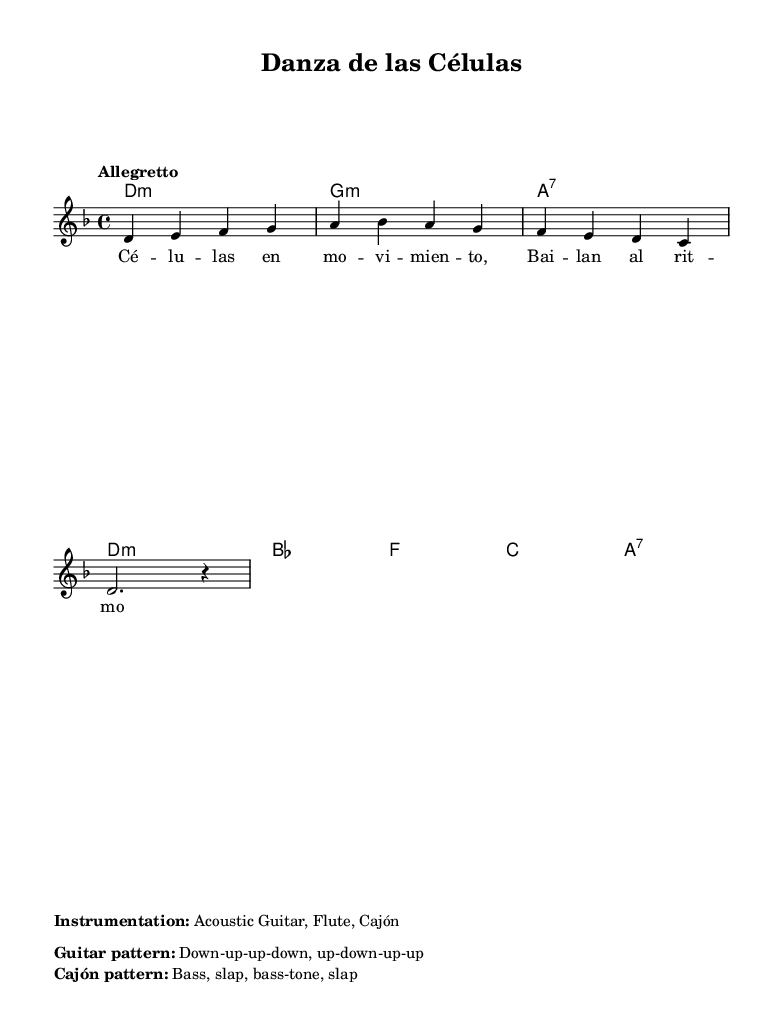What is the key signature of this music? The key signature is D minor, indicated by one flat (B♭) in the staff.
Answer: D minor What is the time signature of this music? The time signature 4/4 is shown at the beginning of the piece, indicating four beats per measure.
Answer: 4/4 What is the tempo marking for this piece? The tempo is marked as "Allegretto," which suggests a moderate pace.
Answer: Allegretto What is the primary texture of the music? The music is primarily homophonic, with a distinct melody supported by chords.
Answer: Homophonic How many measures are in the melody? Counting the measures, the melody consists of four measures shown in the fragment provided.
Answer: Four measures What is the main theme of the lyrics? The lyrics describe cells in motion, reflecting a theme of life and nature.
Answer: Cells in motion What instruments are indicated for this piece? The instrumentation includes Acoustic Guitar, Flute, and Cajón, as specified in the markup section.
Answer: Acoustic Guitar, Flute, Cajón 